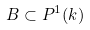Convert formula to latex. <formula><loc_0><loc_0><loc_500><loc_500>B \subset P ^ { 1 } ( k )</formula> 